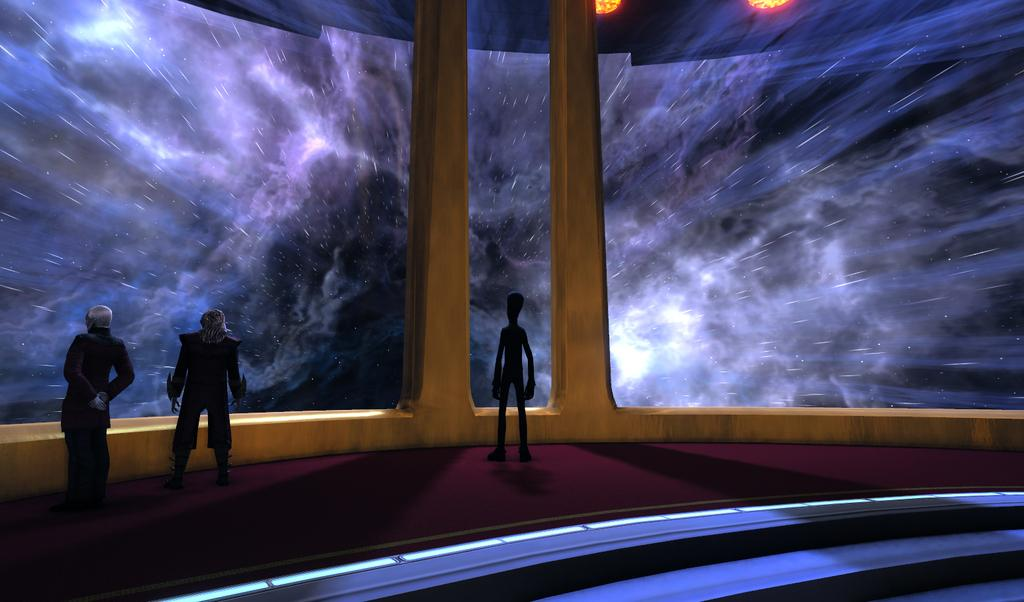What type of characters are depicted in the image? There are animated depictions of persons in the image. What object can be seen in the image? There is a glass in the image. What can be seen through the glass in the image? Thunders are visible in the sky through the glass. What type of show is being performed in the image? There is no indication of a show being performed in the image. What type of destruction can be seen in the image? There is no destruction present in the image. Are there any tents visible in the image? There is no mention of a tent in the provided facts, so it cannot be determined if one is present in the image. 